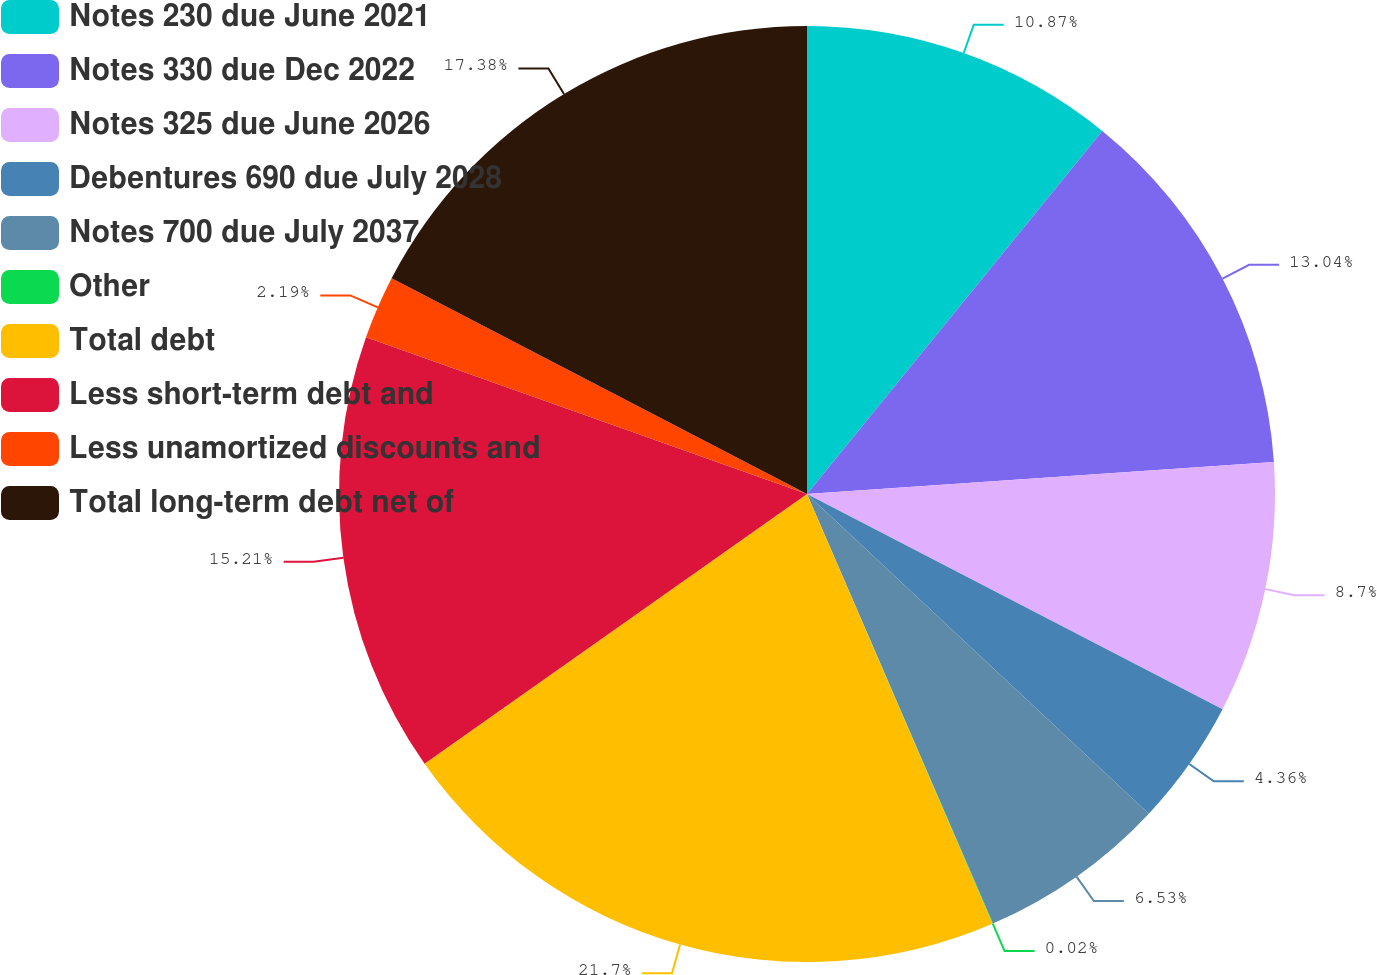Convert chart to OTSL. <chart><loc_0><loc_0><loc_500><loc_500><pie_chart><fcel>Notes 230 due June 2021<fcel>Notes 330 due Dec 2022<fcel>Notes 325 due June 2026<fcel>Debentures 690 due July 2028<fcel>Notes 700 due July 2037<fcel>Other<fcel>Total debt<fcel>Less short-term debt and<fcel>Less unamortized discounts and<fcel>Total long-term debt net of<nl><fcel>10.87%<fcel>13.04%<fcel>8.7%<fcel>4.36%<fcel>6.53%<fcel>0.02%<fcel>21.71%<fcel>15.21%<fcel>2.19%<fcel>17.38%<nl></chart> 